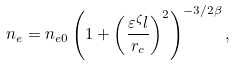Convert formula to latex. <formula><loc_0><loc_0><loc_500><loc_500>n _ { e } = n _ { e 0 } \left ( 1 + \left ( \frac { \varepsilon ^ { \zeta } l } { r _ { c } } \right ) ^ { 2 } \right ) ^ { - 3 / 2 \beta } ,</formula> 